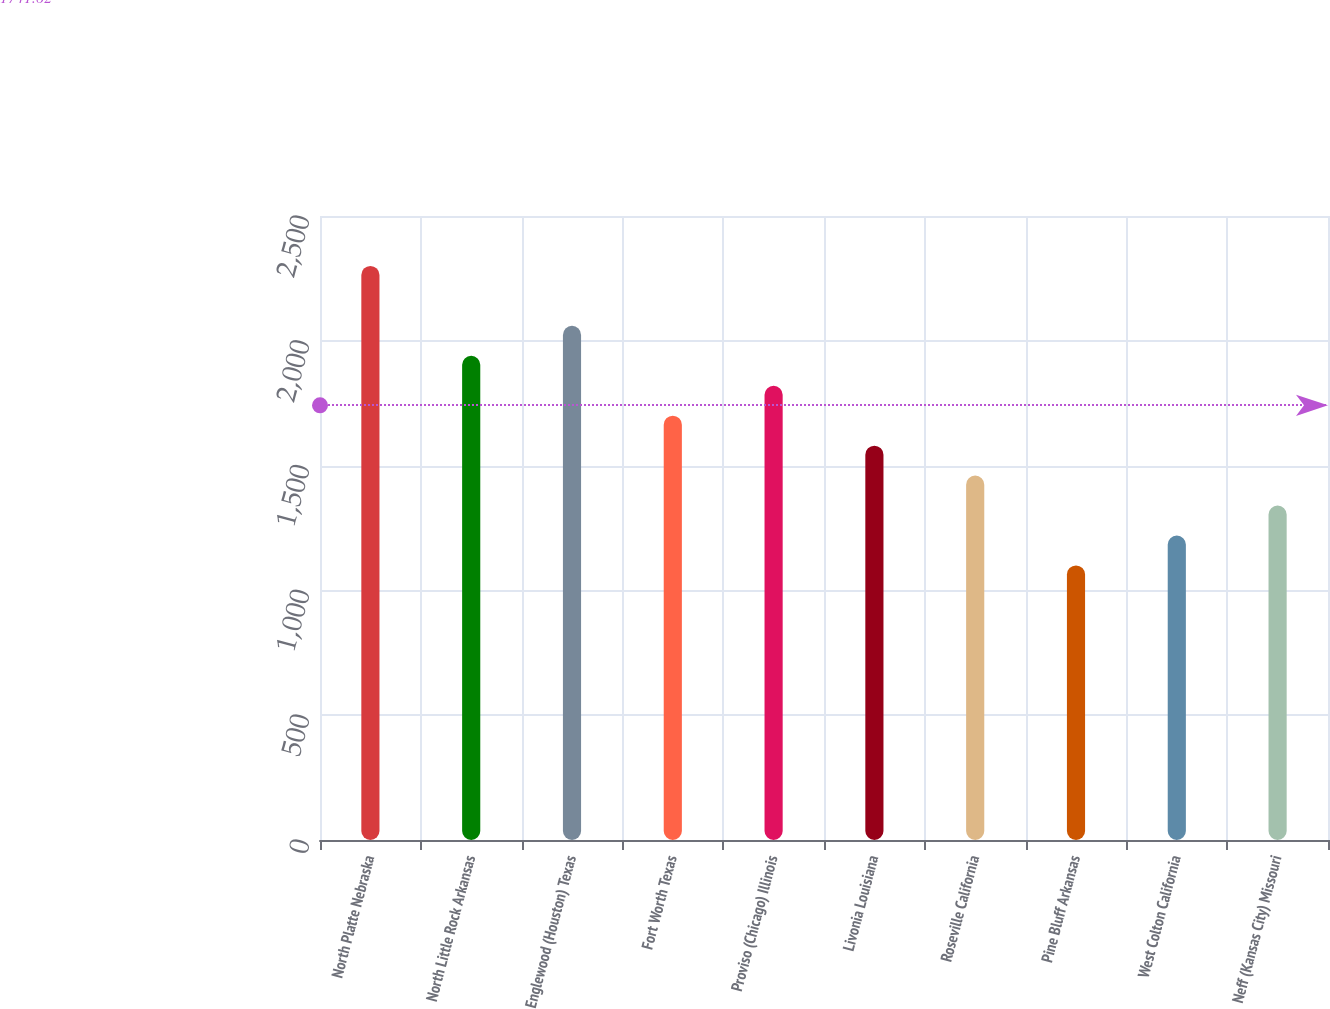<chart> <loc_0><loc_0><loc_500><loc_500><bar_chart><fcel>North Platte Nebraska<fcel>North Little Rock Arkansas<fcel>Englewood (Houston) Texas<fcel>Fort Worth Texas<fcel>Proviso (Chicago) Illinois<fcel>Livonia Louisiana<fcel>Roseville California<fcel>Pine Bluff Arkansas<fcel>West Colton California<fcel>Neff (Kansas City) Missouri<nl><fcel>2300<fcel>1940<fcel>2060<fcel>1700<fcel>1820<fcel>1580<fcel>1460<fcel>1100<fcel>1220<fcel>1340<nl></chart> 